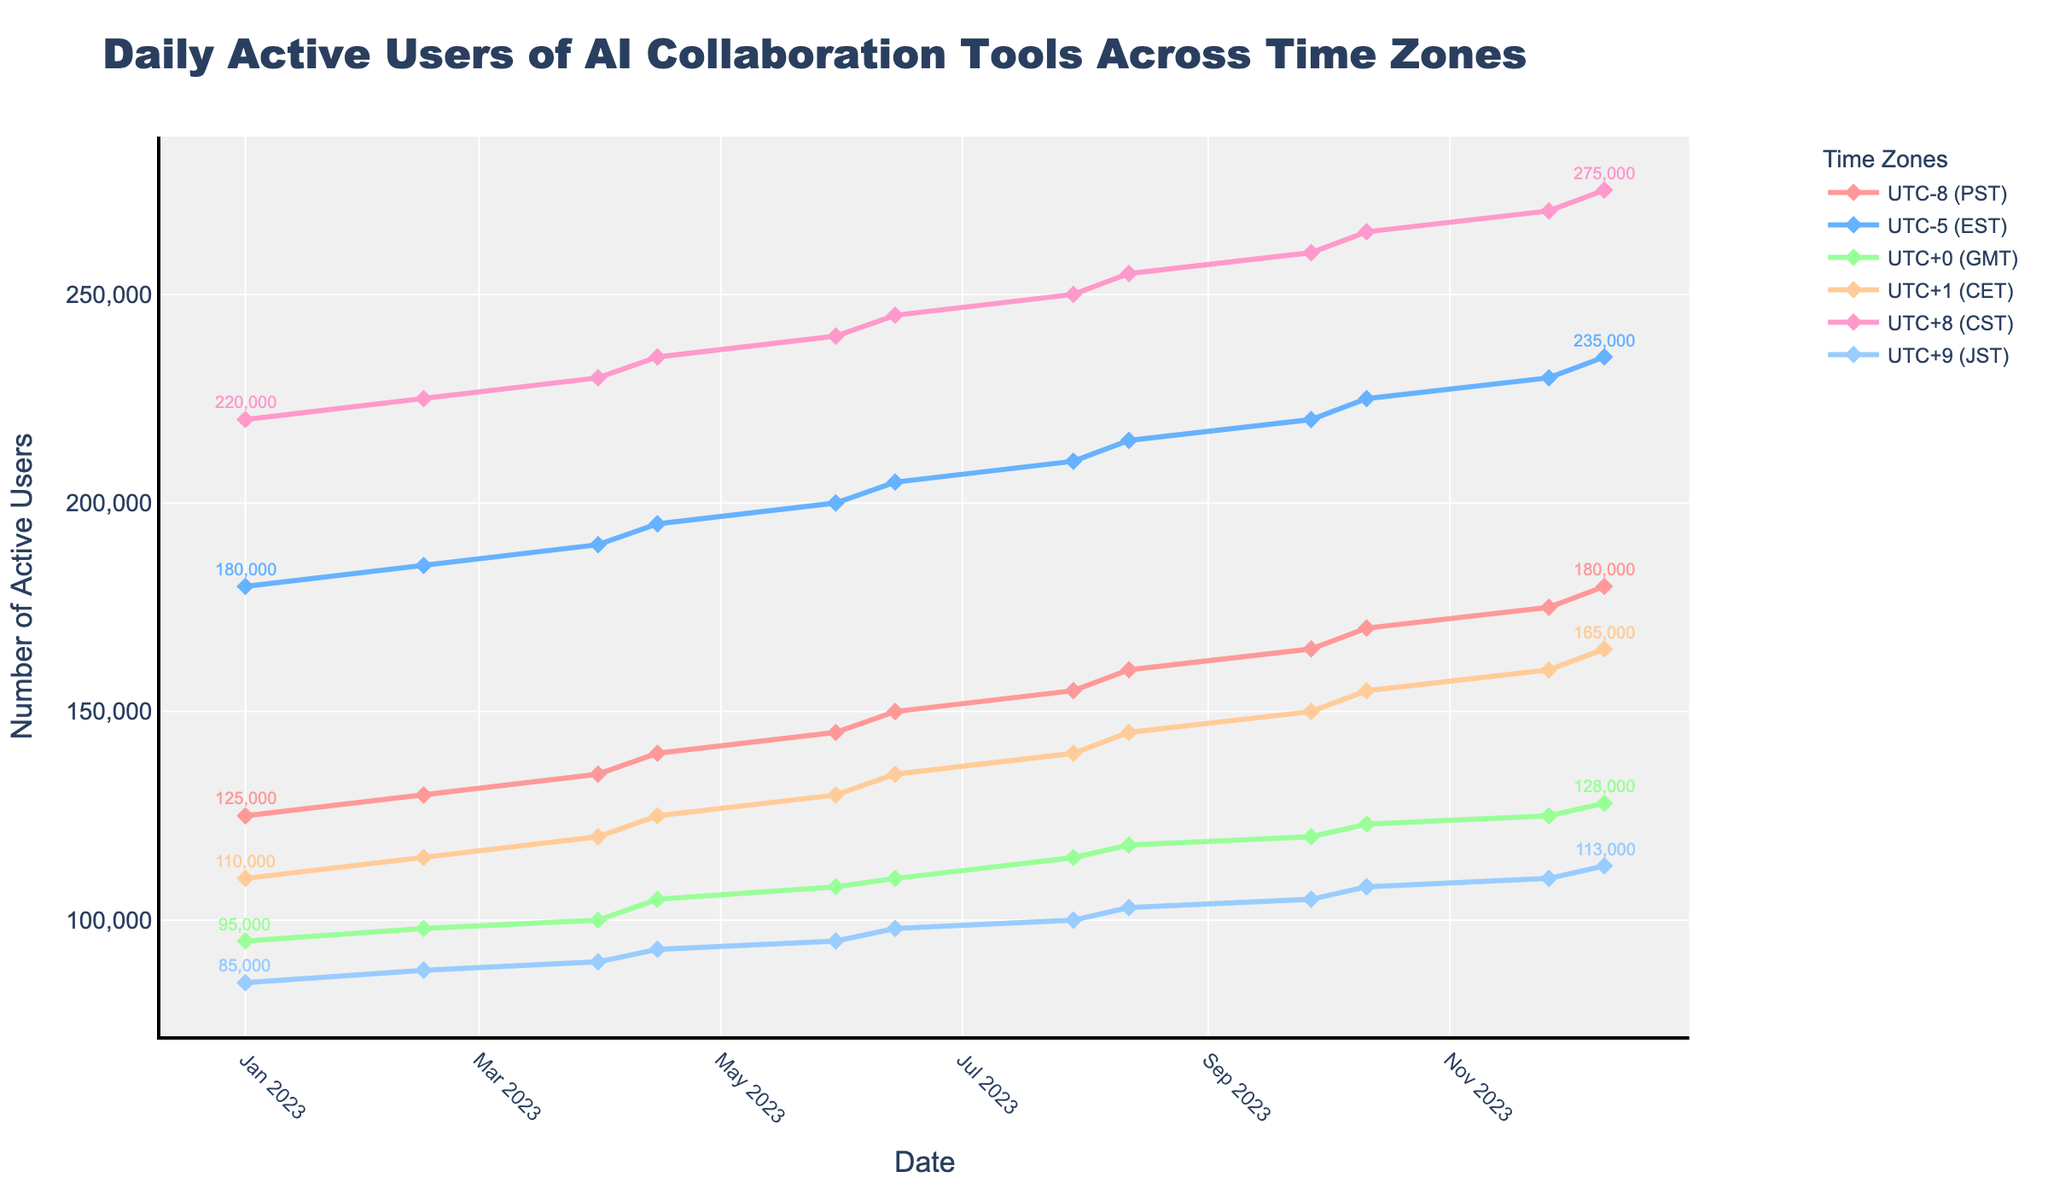Which time zone had the highest number of daily active users at the start of the year? By observing the data at the start of the year, you can see that CST (UTC+8) had the highest number of daily active users on 2023-01-01 with 220,000 users.
Answer: CST (UTC+8) Did the number of daily active users increase or decrease overall for the PST time zone throughout the year? By looking at the trend line for PST (UTC-8) from January to December, the line shows an upward trend, indicating that the number of daily active users increased.
Answer: Increase Which two time zones showed the smallest change in the number of daily active users between the start and the end of the year? To determine this, calculate the differences between the starting and ending values. CET (UTC+1) changed from 110,000 to 165,000 (55,000) and JST (UTC+9) changed from 85,000 to 113,000 (28,000), showing the smallest changes.
Answer: CET (UTC+1) and JST (UTC+9) What is the difference between the maximum and minimum daily active users for EST (UTC-5) across the entire year? The maximum for EST is 235,000 (in December) and the minimum is 180,000 (in January). The difference is 235,000 - 180,000.
Answer: 55,000 Which month shows the highest jump in the number of daily active users for CST (UTC+8)? By checking the differences between each data point for CST (UTC+8), the highest increase is from 2023-06-14 (245,000) to 2023-07-29 (250,000), hence the highest jump of 5,000 users in July.
Answer: July What is the combined number of daily active users for PST (UTC-8) and GMT (UTC+0) as of the end of the year? At the end of the year (2023-12-10), PST has 180,000 users and GMT has 128,000 users. The combined number is 180,000 + 128,000.
Answer: 308,000 Which time zone has the most gradual increase in daily active users throughout the year? Observing the slopes of the trend lines, GMT (UTC+0) has the most gradual (least steep) increase in daily active users.
Answer: GMT (UTC+0) How many more daily active users did CET (UTC+1) have in November compared to May? In November (2023-11-26), CET had 160,000 users, and in May (2023-05-30), it had 130,000 users. The difference is 160,000 - 130,000.
Answer: 30,000 